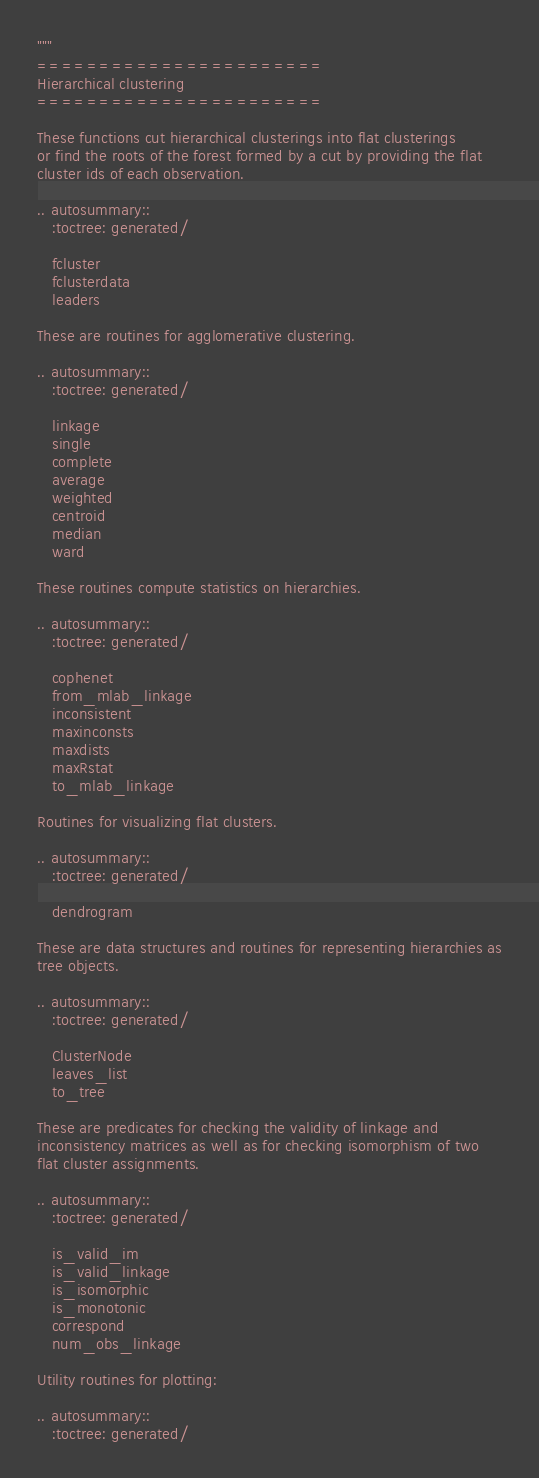Convert code to text. <code><loc_0><loc_0><loc_500><loc_500><_Python_>"""
=======================
Hierarchical clustering
=======================

These functions cut hierarchical clusterings into flat clusterings
or find the roots of the forest formed by a cut by providing the flat
cluster ids of each observation.

.. autosummary::
   :toctree: generated/

   fcluster
   fclusterdata
   leaders

These are routines for agglomerative clustering.

.. autosummary::
   :toctree: generated/

   linkage
   single
   complete
   average
   weighted
   centroid
   median
   ward

These routines compute statistics on hierarchies.

.. autosummary::
   :toctree: generated/

   cophenet
   from_mlab_linkage
   inconsistent
   maxinconsts
   maxdists
   maxRstat
   to_mlab_linkage

Routines for visualizing flat clusters.

.. autosummary::
   :toctree: generated/

   dendrogram

These are data structures and routines for representing hierarchies as
tree objects.

.. autosummary::
   :toctree: generated/

   ClusterNode
   leaves_list
   to_tree

These are predicates for checking the validity of linkage and
inconsistency matrices as well as for checking isomorphism of two
flat cluster assignments.

.. autosummary::
   :toctree: generated/

   is_valid_im
   is_valid_linkage
   is_isomorphic
   is_monotonic
   correspond
   num_obs_linkage

Utility routines for plotting:

.. autosummary::
   :toctree: generated/
</code> 